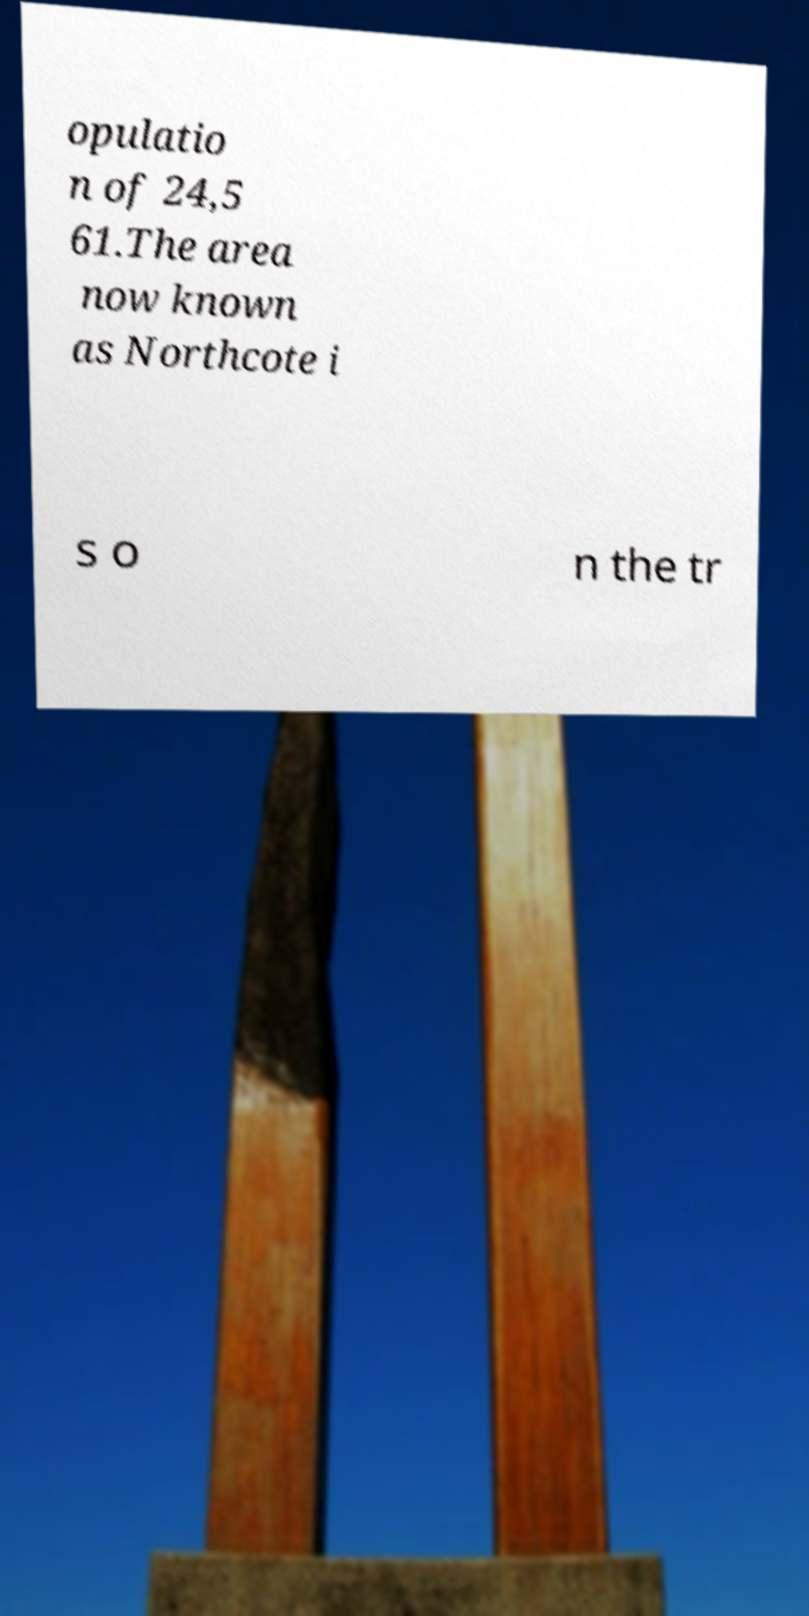Could you assist in decoding the text presented in this image and type it out clearly? opulatio n of 24,5 61.The area now known as Northcote i s o n the tr 